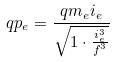Convert formula to latex. <formula><loc_0><loc_0><loc_500><loc_500>q p _ { e } = \frac { q m _ { e } i _ { e } } { \sqrt { 1 \cdot \frac { i _ { e } ^ { 3 } } { f ^ { 3 } } } }</formula> 